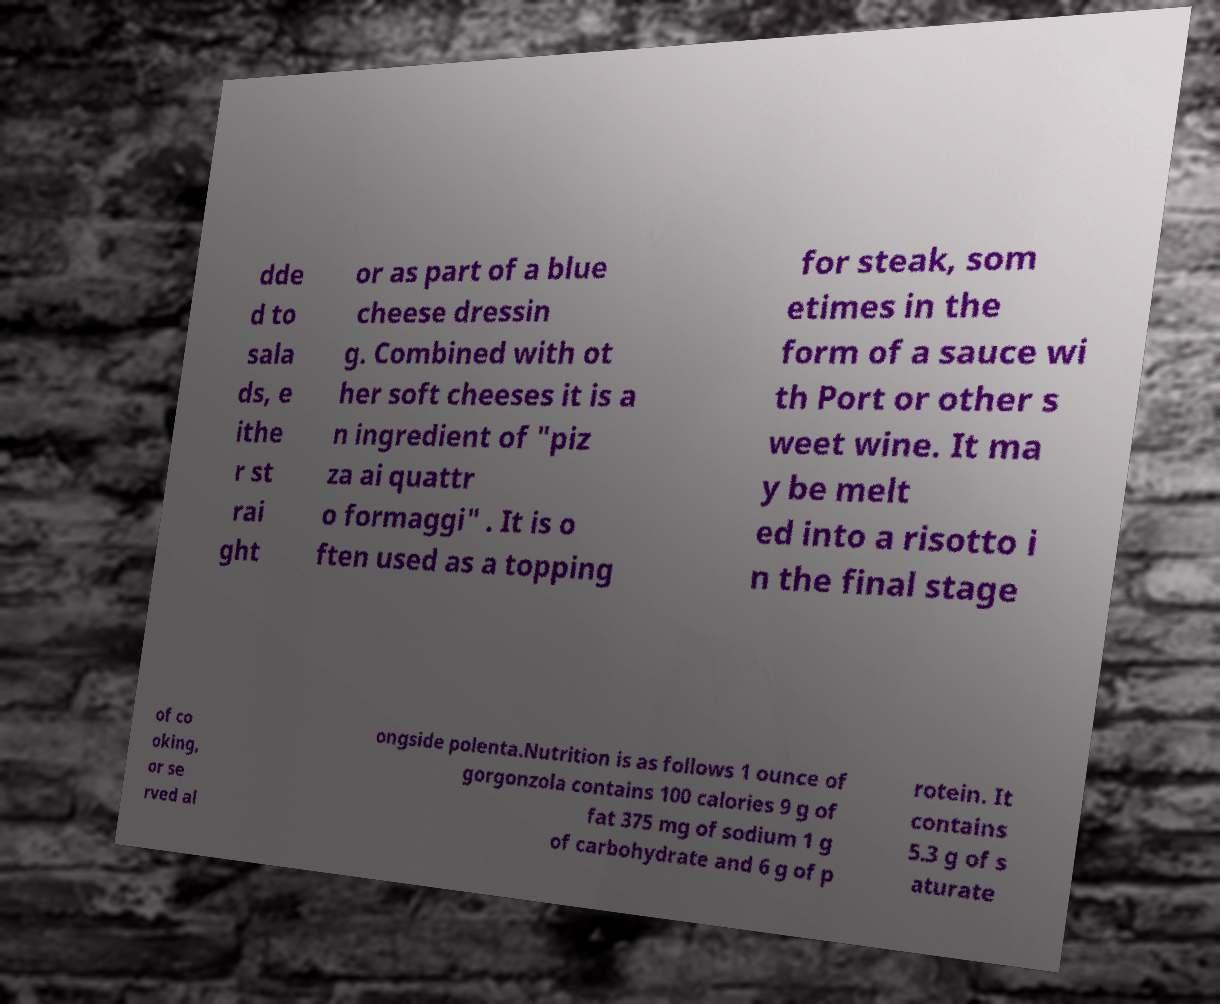Can you explain how the gorgonzola cheese being discussed in this image can be integrated into various cuisines or dishes? Gorgonzola, a versatile blue cheese from Italy, can enhance many dishes. It can be crumbled over salads for a rich, tangy flavor or used in dressings. In Italian cuisine, it's often found in 'pizza ai quattro formaggi'. Another popular use is as a steak topping, either directly crumbled or melted into a decadent Port wine sauce. Additionally, it adds creamy complexity when melted into risottos or served with rustic polenta. 